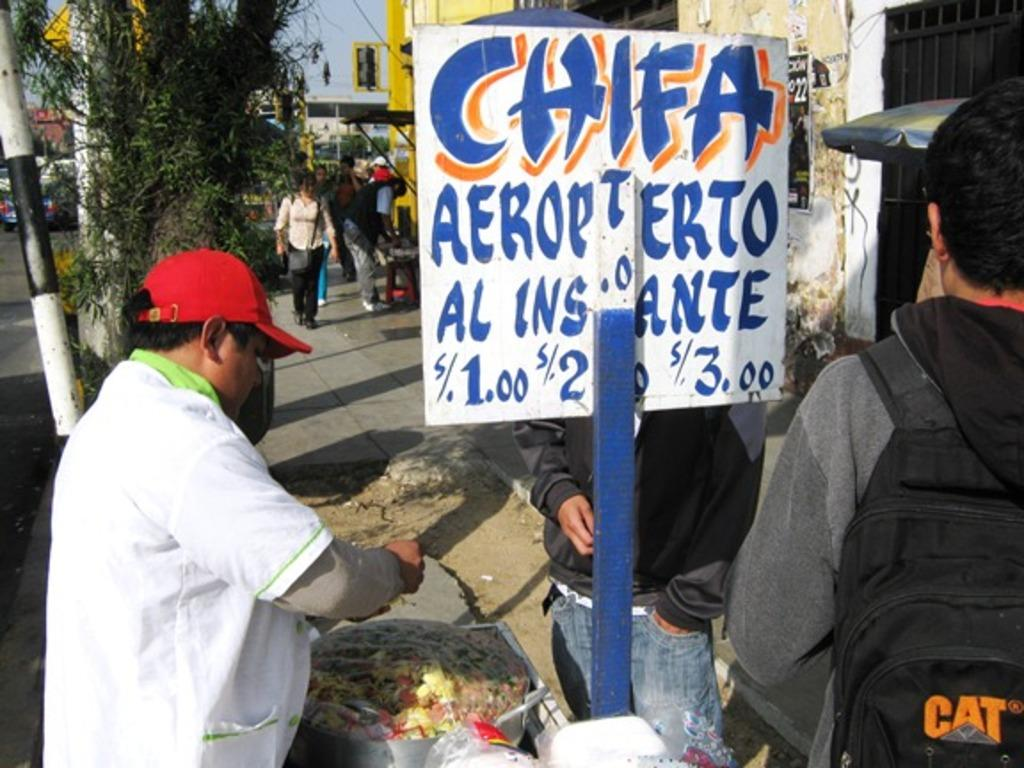What can be seen at the bottom of the image? There are people standing at the bottom of the image. What is present in the image besides the people? There is a banner in the image. What can be seen in the background of the image? There are trees, buildings, poles, and sign boards visible in the background. What type of approval does the society in the image give to the rest? There is no indication of a society or rest in the image, as it only features people, a banner, and various elements in the background. 